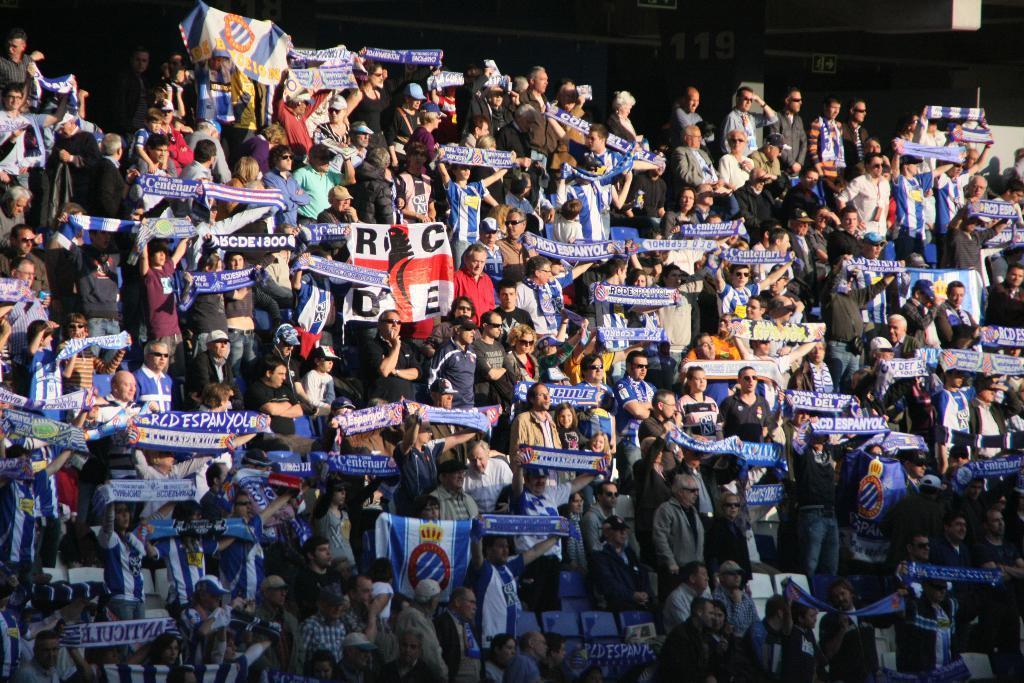Could you give a brief overview of what you see in this image? In this image I can see a crowd of people standing, holding blue color flags in the hands. On the flags, I can see the text. It seems to be a stadium. The background is dark. 